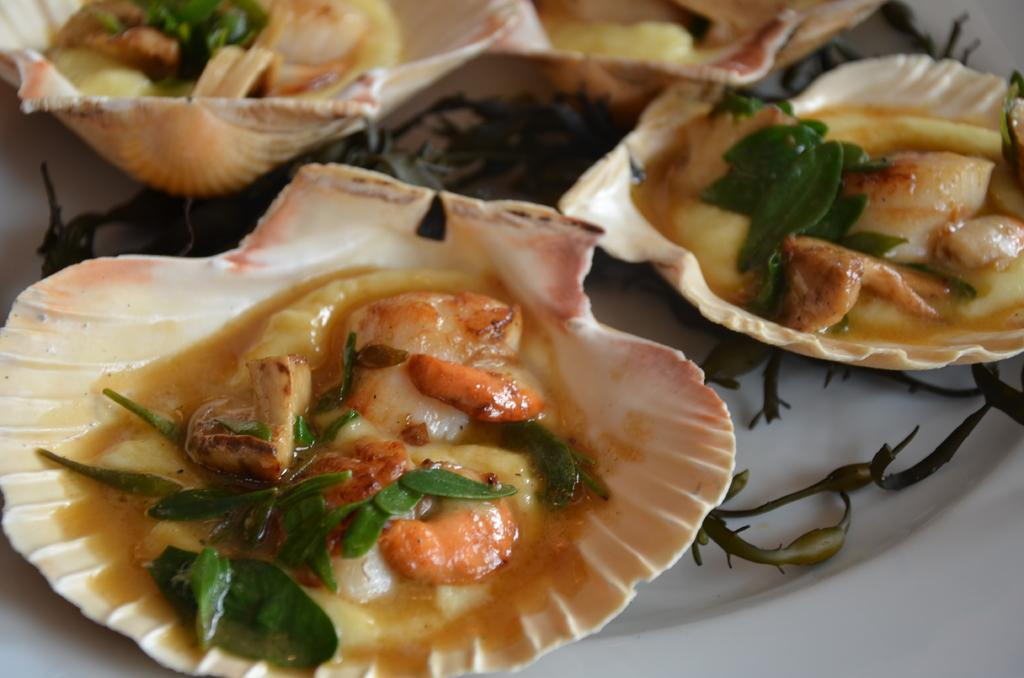What is the main subject of the image? The main subject of the image is food items on shells. How are the shells arranged in the image? The shells are placed on a plate in the image. What type of spark can be seen coming from the shells in the image? There is no spark present in the image; it features food items on shells placed on a plate. 